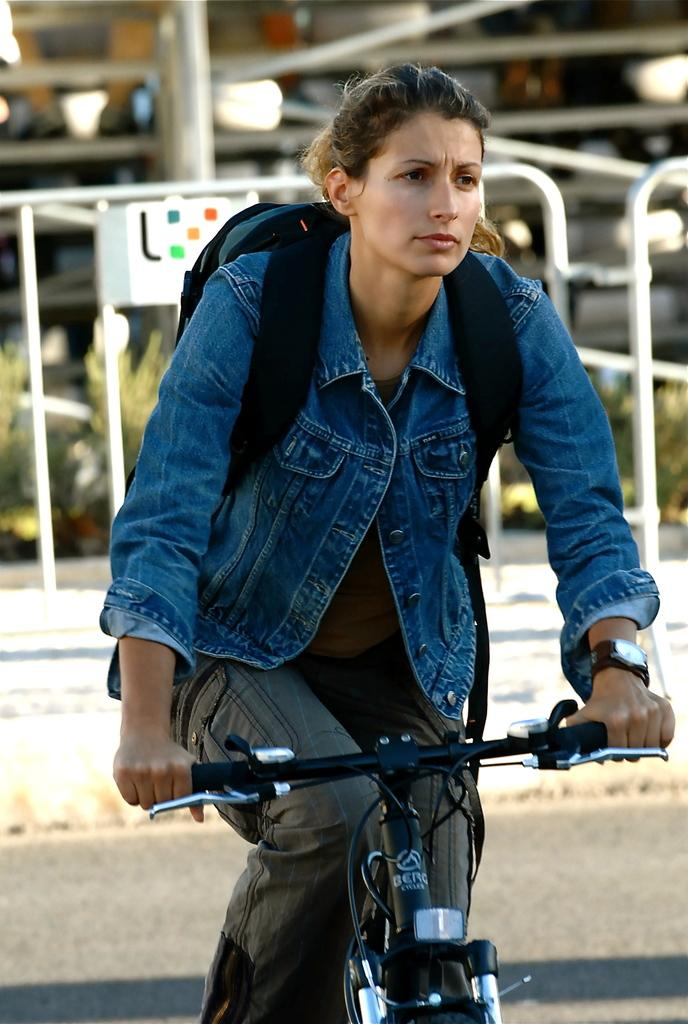Who is the main subject in the picture? There is a woman in the picture. What is the woman doing in the image? The woman is riding a bicycle. What can be seen in the background behind the woman? There is an iron fence behind the woman. What type of train can be seen passing by in the image? There is no train present in the image; it features a woman riding a bicycle with an iron fence in the background. 